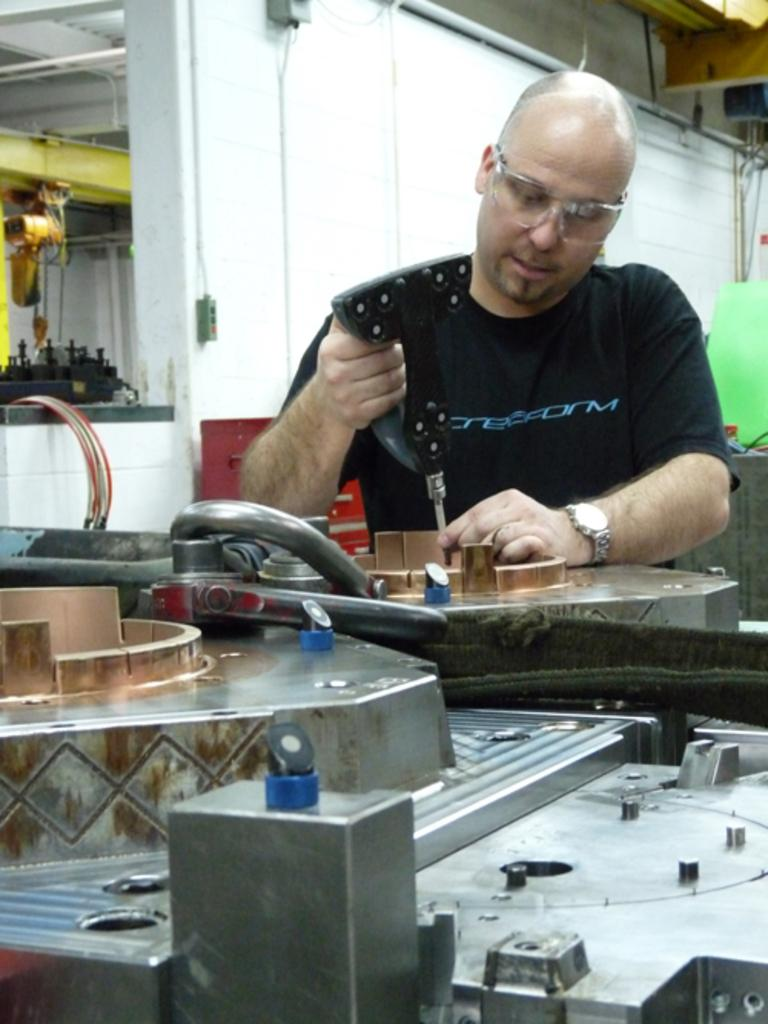What type of equipment can be seen in the image? There are machines in the image. What is the person holding in the image? The person is holding a hand drilling machine. What is the person doing with the hand drilling machine? The person is repairing something. What is the background of the image? There is a wall in the image. What else can be seen in the image besides the machines and the person? Cables are present in the image. What type of yam is being used to stop the trail in the image? There is no yam or trail present in the image. 